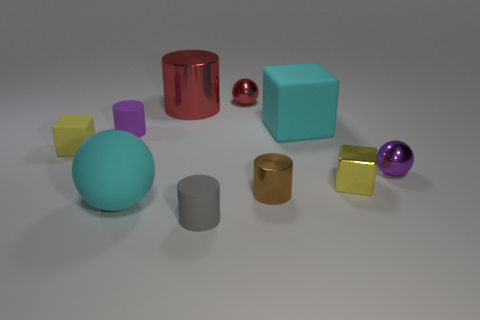Do the brown metal object and the big red metal thing have the same shape?
Offer a very short reply. Yes. What number of objects are on the left side of the large red metallic object and behind the purple shiny thing?
Provide a succinct answer. 2. Is the number of small brown metal cylinders that are on the right side of the tiny yellow shiny block the same as the number of brown metallic things that are in front of the big red cylinder?
Offer a very short reply. No. Do the ball that is behind the small purple shiny object and the cyan rubber thing that is behind the tiny purple metal object have the same size?
Offer a terse response. No. What is the ball that is to the left of the purple metallic object and in front of the small rubber cube made of?
Your response must be concise. Rubber. Is the number of tiny brown cylinders less than the number of blue metal blocks?
Offer a terse response. No. There is a cylinder that is behind the big cyan object behind the small purple shiny thing; what size is it?
Keep it short and to the point. Large. What shape is the small brown metallic thing that is in front of the yellow thing that is to the left of the large cyan thing that is left of the large cyan block?
Ensure brevity in your answer.  Cylinder. The cylinder that is the same material as the brown object is what color?
Provide a succinct answer. Red. There is a tiny shiny sphere on the left side of the tiny purple object that is in front of the small rubber cube that is on the left side of the small purple matte thing; what color is it?
Make the answer very short. Red. 